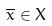Convert formula to latex. <formula><loc_0><loc_0><loc_500><loc_500>\overline { x } \in X</formula> 